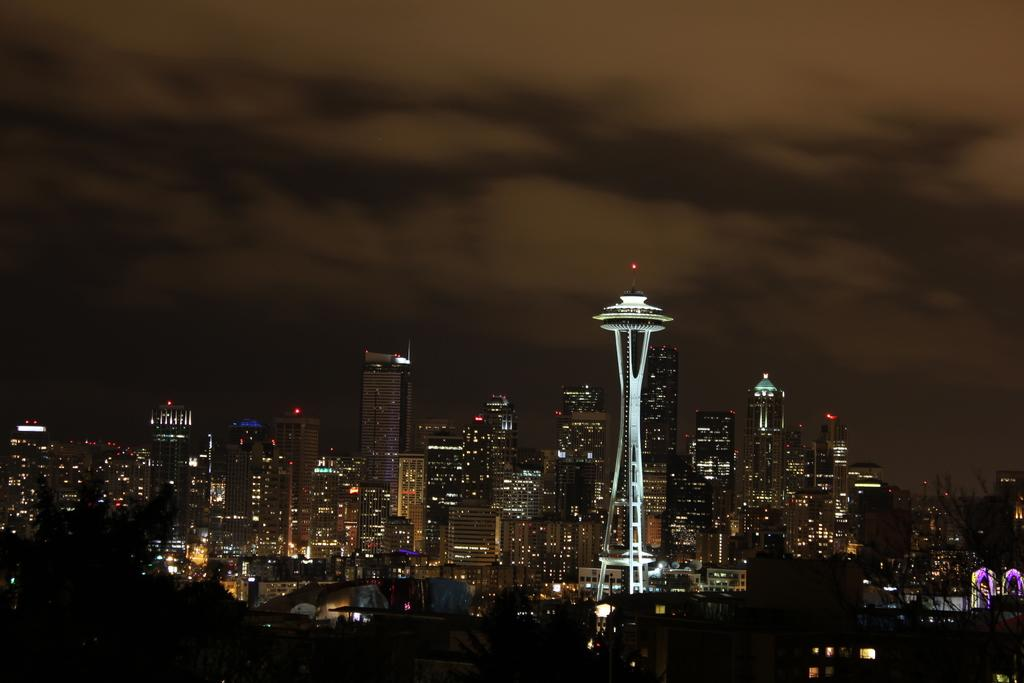What type of structures can be seen in the image? There are many buildings in the image, including skyscrapers. Can you describe the sky in the background of the image? There are clouds visible in the sky in the background of the image. How much tax is being collected from the children in the image? There are no children present in the image, and therefore no tax collection can be observed. What type of lumber is being used to construct the buildings in the image? The image does not provide information about the materials used to construct the buildings, so it cannot be determined from the image. 